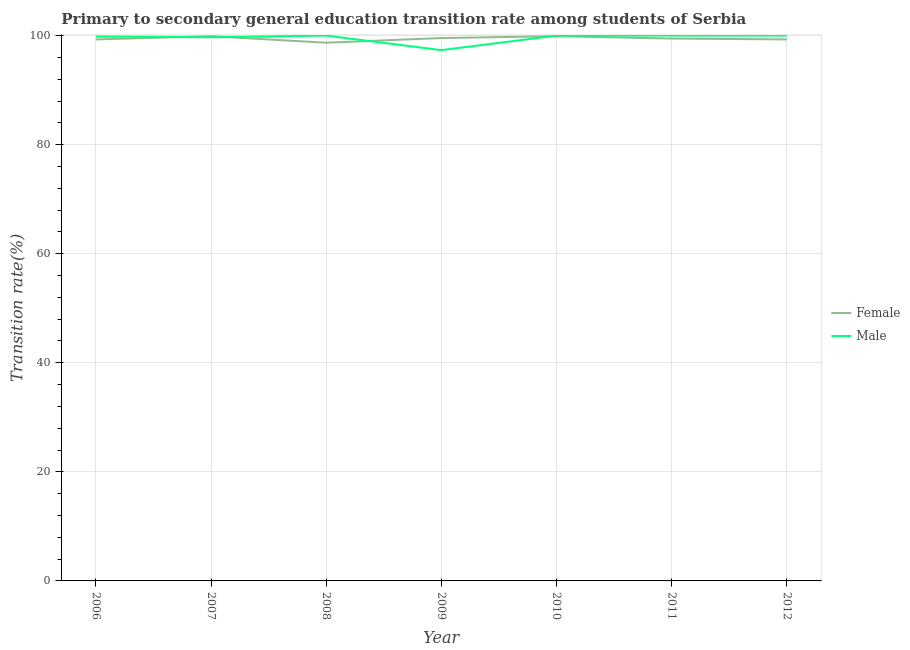How many different coloured lines are there?
Provide a short and direct response. 2. Is the number of lines equal to the number of legend labels?
Your answer should be very brief. Yes. What is the transition rate among female students in 2009?
Make the answer very short. 99.55. Across all years, what is the maximum transition rate among male students?
Offer a terse response. 100. Across all years, what is the minimum transition rate among female students?
Ensure brevity in your answer.  98.7. In which year was the transition rate among male students maximum?
Your answer should be compact. 2008. In which year was the transition rate among female students minimum?
Make the answer very short. 2008. What is the total transition rate among male students in the graph?
Make the answer very short. 696.86. What is the difference between the transition rate among female students in 2007 and that in 2008?
Offer a very short reply. 1.19. What is the difference between the transition rate among male students in 2011 and the transition rate among female students in 2010?
Your answer should be very brief. 0.11. What is the average transition rate among female students per year?
Your answer should be compact. 99.44. In the year 2011, what is the difference between the transition rate among male students and transition rate among female students?
Offer a very short reply. 0.54. In how many years, is the transition rate among male students greater than 52 %?
Offer a terse response. 7. Is the transition rate among male students in 2009 less than that in 2012?
Offer a very short reply. Yes. What is the difference between the highest and the second highest transition rate among female students?
Your response must be concise. 0.01. What is the difference between the highest and the lowest transition rate among female students?
Offer a very short reply. 1.2. In how many years, is the transition rate among female students greater than the average transition rate among female students taken over all years?
Offer a terse response. 4. Is the sum of the transition rate among male students in 2007 and 2010 greater than the maximum transition rate among female students across all years?
Provide a succinct answer. Yes. Does the transition rate among male students monotonically increase over the years?
Your answer should be compact. No. How many years are there in the graph?
Make the answer very short. 7. What is the difference between two consecutive major ticks on the Y-axis?
Your answer should be very brief. 20. Does the graph contain any zero values?
Your response must be concise. No. Does the graph contain grids?
Your answer should be very brief. Yes. Where does the legend appear in the graph?
Offer a terse response. Center right. How many legend labels are there?
Provide a short and direct response. 2. How are the legend labels stacked?
Offer a terse response. Vertical. What is the title of the graph?
Offer a terse response. Primary to secondary general education transition rate among students of Serbia. What is the label or title of the X-axis?
Keep it short and to the point. Year. What is the label or title of the Y-axis?
Give a very brief answer. Transition rate(%). What is the Transition rate(%) in Female in 2006?
Provide a succinct answer. 99.3. What is the Transition rate(%) of Male in 2006?
Your answer should be very brief. 99.83. What is the Transition rate(%) of Female in 2007?
Keep it short and to the point. 99.88. What is the Transition rate(%) in Male in 2007?
Keep it short and to the point. 99.69. What is the Transition rate(%) in Female in 2008?
Give a very brief answer. 98.7. What is the Transition rate(%) in Female in 2009?
Provide a succinct answer. 99.55. What is the Transition rate(%) of Male in 2009?
Ensure brevity in your answer.  97.33. What is the Transition rate(%) in Female in 2010?
Provide a succinct answer. 99.89. What is the Transition rate(%) in Female in 2011?
Offer a terse response. 99.46. What is the Transition rate(%) of Male in 2011?
Give a very brief answer. 100. What is the Transition rate(%) of Female in 2012?
Provide a succinct answer. 99.3. Across all years, what is the maximum Transition rate(%) of Female?
Ensure brevity in your answer.  99.89. Across all years, what is the maximum Transition rate(%) in Male?
Make the answer very short. 100. Across all years, what is the minimum Transition rate(%) in Female?
Offer a very short reply. 98.7. Across all years, what is the minimum Transition rate(%) in Male?
Your response must be concise. 97.33. What is the total Transition rate(%) in Female in the graph?
Provide a succinct answer. 696.08. What is the total Transition rate(%) of Male in the graph?
Make the answer very short. 696.86. What is the difference between the Transition rate(%) of Female in 2006 and that in 2007?
Give a very brief answer. -0.59. What is the difference between the Transition rate(%) of Male in 2006 and that in 2007?
Offer a very short reply. 0.14. What is the difference between the Transition rate(%) of Female in 2006 and that in 2008?
Provide a short and direct response. 0.6. What is the difference between the Transition rate(%) in Male in 2006 and that in 2008?
Your answer should be compact. -0.17. What is the difference between the Transition rate(%) of Female in 2006 and that in 2009?
Offer a very short reply. -0.25. What is the difference between the Transition rate(%) in Male in 2006 and that in 2009?
Keep it short and to the point. 2.5. What is the difference between the Transition rate(%) of Female in 2006 and that in 2010?
Your answer should be compact. -0.59. What is the difference between the Transition rate(%) of Male in 2006 and that in 2010?
Your answer should be very brief. -0.17. What is the difference between the Transition rate(%) of Female in 2006 and that in 2011?
Give a very brief answer. -0.16. What is the difference between the Transition rate(%) of Male in 2006 and that in 2011?
Offer a terse response. -0.17. What is the difference between the Transition rate(%) in Female in 2006 and that in 2012?
Make the answer very short. 0. What is the difference between the Transition rate(%) in Male in 2006 and that in 2012?
Keep it short and to the point. -0.17. What is the difference between the Transition rate(%) in Female in 2007 and that in 2008?
Your answer should be very brief. 1.19. What is the difference between the Transition rate(%) of Male in 2007 and that in 2008?
Ensure brevity in your answer.  -0.31. What is the difference between the Transition rate(%) of Female in 2007 and that in 2009?
Offer a terse response. 0.33. What is the difference between the Transition rate(%) in Male in 2007 and that in 2009?
Offer a very short reply. 2.36. What is the difference between the Transition rate(%) in Female in 2007 and that in 2010?
Ensure brevity in your answer.  -0.01. What is the difference between the Transition rate(%) in Male in 2007 and that in 2010?
Ensure brevity in your answer.  -0.31. What is the difference between the Transition rate(%) in Female in 2007 and that in 2011?
Provide a succinct answer. 0.43. What is the difference between the Transition rate(%) of Male in 2007 and that in 2011?
Give a very brief answer. -0.31. What is the difference between the Transition rate(%) in Female in 2007 and that in 2012?
Offer a very short reply. 0.59. What is the difference between the Transition rate(%) in Male in 2007 and that in 2012?
Your answer should be very brief. -0.31. What is the difference between the Transition rate(%) in Female in 2008 and that in 2009?
Your response must be concise. -0.86. What is the difference between the Transition rate(%) in Male in 2008 and that in 2009?
Give a very brief answer. 2.67. What is the difference between the Transition rate(%) in Female in 2008 and that in 2010?
Your answer should be very brief. -1.2. What is the difference between the Transition rate(%) in Female in 2008 and that in 2011?
Offer a very short reply. -0.76. What is the difference between the Transition rate(%) in Female in 2008 and that in 2012?
Offer a very short reply. -0.6. What is the difference between the Transition rate(%) of Male in 2008 and that in 2012?
Keep it short and to the point. 0. What is the difference between the Transition rate(%) of Female in 2009 and that in 2010?
Keep it short and to the point. -0.34. What is the difference between the Transition rate(%) in Male in 2009 and that in 2010?
Your response must be concise. -2.67. What is the difference between the Transition rate(%) in Female in 2009 and that in 2011?
Give a very brief answer. 0.09. What is the difference between the Transition rate(%) of Male in 2009 and that in 2011?
Make the answer very short. -2.67. What is the difference between the Transition rate(%) of Female in 2009 and that in 2012?
Your answer should be very brief. 0.25. What is the difference between the Transition rate(%) in Male in 2009 and that in 2012?
Make the answer very short. -2.67. What is the difference between the Transition rate(%) in Female in 2010 and that in 2011?
Keep it short and to the point. 0.43. What is the difference between the Transition rate(%) in Female in 2010 and that in 2012?
Your answer should be very brief. 0.59. What is the difference between the Transition rate(%) of Female in 2011 and that in 2012?
Your answer should be compact. 0.16. What is the difference between the Transition rate(%) in Female in 2006 and the Transition rate(%) in Male in 2007?
Ensure brevity in your answer.  -0.39. What is the difference between the Transition rate(%) of Female in 2006 and the Transition rate(%) of Male in 2008?
Keep it short and to the point. -0.7. What is the difference between the Transition rate(%) of Female in 2006 and the Transition rate(%) of Male in 2009?
Your answer should be compact. 1.96. What is the difference between the Transition rate(%) in Female in 2006 and the Transition rate(%) in Male in 2010?
Provide a succinct answer. -0.7. What is the difference between the Transition rate(%) of Female in 2006 and the Transition rate(%) of Male in 2011?
Your response must be concise. -0.7. What is the difference between the Transition rate(%) of Female in 2006 and the Transition rate(%) of Male in 2012?
Provide a short and direct response. -0.7. What is the difference between the Transition rate(%) of Female in 2007 and the Transition rate(%) of Male in 2008?
Give a very brief answer. -0.12. What is the difference between the Transition rate(%) of Female in 2007 and the Transition rate(%) of Male in 2009?
Provide a succinct answer. 2.55. What is the difference between the Transition rate(%) in Female in 2007 and the Transition rate(%) in Male in 2010?
Your answer should be very brief. -0.12. What is the difference between the Transition rate(%) of Female in 2007 and the Transition rate(%) of Male in 2011?
Make the answer very short. -0.12. What is the difference between the Transition rate(%) of Female in 2007 and the Transition rate(%) of Male in 2012?
Ensure brevity in your answer.  -0.12. What is the difference between the Transition rate(%) of Female in 2008 and the Transition rate(%) of Male in 2009?
Keep it short and to the point. 1.36. What is the difference between the Transition rate(%) of Female in 2008 and the Transition rate(%) of Male in 2010?
Keep it short and to the point. -1.3. What is the difference between the Transition rate(%) of Female in 2008 and the Transition rate(%) of Male in 2011?
Offer a very short reply. -1.3. What is the difference between the Transition rate(%) in Female in 2008 and the Transition rate(%) in Male in 2012?
Provide a short and direct response. -1.3. What is the difference between the Transition rate(%) of Female in 2009 and the Transition rate(%) of Male in 2010?
Ensure brevity in your answer.  -0.45. What is the difference between the Transition rate(%) in Female in 2009 and the Transition rate(%) in Male in 2011?
Your response must be concise. -0.45. What is the difference between the Transition rate(%) of Female in 2009 and the Transition rate(%) of Male in 2012?
Provide a short and direct response. -0.45. What is the difference between the Transition rate(%) of Female in 2010 and the Transition rate(%) of Male in 2011?
Your response must be concise. -0.11. What is the difference between the Transition rate(%) of Female in 2010 and the Transition rate(%) of Male in 2012?
Provide a short and direct response. -0.11. What is the difference between the Transition rate(%) in Female in 2011 and the Transition rate(%) in Male in 2012?
Your answer should be very brief. -0.54. What is the average Transition rate(%) of Female per year?
Provide a short and direct response. 99.44. What is the average Transition rate(%) of Male per year?
Ensure brevity in your answer.  99.55. In the year 2006, what is the difference between the Transition rate(%) in Female and Transition rate(%) in Male?
Your answer should be very brief. -0.53. In the year 2007, what is the difference between the Transition rate(%) of Female and Transition rate(%) of Male?
Ensure brevity in your answer.  0.19. In the year 2008, what is the difference between the Transition rate(%) of Female and Transition rate(%) of Male?
Ensure brevity in your answer.  -1.3. In the year 2009, what is the difference between the Transition rate(%) in Female and Transition rate(%) in Male?
Ensure brevity in your answer.  2.22. In the year 2010, what is the difference between the Transition rate(%) of Female and Transition rate(%) of Male?
Your answer should be very brief. -0.11. In the year 2011, what is the difference between the Transition rate(%) of Female and Transition rate(%) of Male?
Ensure brevity in your answer.  -0.54. In the year 2012, what is the difference between the Transition rate(%) in Female and Transition rate(%) in Male?
Make the answer very short. -0.7. What is the ratio of the Transition rate(%) of Female in 2006 to that in 2007?
Your answer should be very brief. 0.99. What is the ratio of the Transition rate(%) in Male in 2006 to that in 2007?
Your answer should be compact. 1. What is the ratio of the Transition rate(%) of Female in 2006 to that in 2008?
Provide a short and direct response. 1.01. What is the ratio of the Transition rate(%) in Male in 2006 to that in 2009?
Make the answer very short. 1.03. What is the ratio of the Transition rate(%) in Male in 2006 to that in 2011?
Make the answer very short. 1. What is the ratio of the Transition rate(%) of Female in 2006 to that in 2012?
Your answer should be compact. 1. What is the ratio of the Transition rate(%) in Male in 2006 to that in 2012?
Offer a very short reply. 1. What is the ratio of the Transition rate(%) in Female in 2007 to that in 2008?
Give a very brief answer. 1.01. What is the ratio of the Transition rate(%) of Male in 2007 to that in 2008?
Your response must be concise. 1. What is the ratio of the Transition rate(%) in Female in 2007 to that in 2009?
Provide a short and direct response. 1. What is the ratio of the Transition rate(%) in Male in 2007 to that in 2009?
Make the answer very short. 1.02. What is the ratio of the Transition rate(%) of Female in 2007 to that in 2011?
Provide a succinct answer. 1. What is the ratio of the Transition rate(%) of Male in 2007 to that in 2011?
Your response must be concise. 1. What is the ratio of the Transition rate(%) of Female in 2007 to that in 2012?
Give a very brief answer. 1.01. What is the ratio of the Transition rate(%) in Male in 2007 to that in 2012?
Your answer should be compact. 1. What is the ratio of the Transition rate(%) in Female in 2008 to that in 2009?
Offer a terse response. 0.99. What is the ratio of the Transition rate(%) in Male in 2008 to that in 2009?
Provide a succinct answer. 1.03. What is the ratio of the Transition rate(%) in Female in 2008 to that in 2010?
Keep it short and to the point. 0.99. What is the ratio of the Transition rate(%) in Male in 2008 to that in 2011?
Provide a short and direct response. 1. What is the ratio of the Transition rate(%) in Female in 2008 to that in 2012?
Provide a succinct answer. 0.99. What is the ratio of the Transition rate(%) of Male in 2008 to that in 2012?
Your response must be concise. 1. What is the ratio of the Transition rate(%) of Female in 2009 to that in 2010?
Offer a terse response. 1. What is the ratio of the Transition rate(%) of Male in 2009 to that in 2010?
Offer a terse response. 0.97. What is the ratio of the Transition rate(%) in Female in 2009 to that in 2011?
Offer a terse response. 1. What is the ratio of the Transition rate(%) of Male in 2009 to that in 2011?
Your answer should be very brief. 0.97. What is the ratio of the Transition rate(%) in Male in 2009 to that in 2012?
Your answer should be compact. 0.97. What is the ratio of the Transition rate(%) in Female in 2010 to that in 2011?
Ensure brevity in your answer.  1. What is the ratio of the Transition rate(%) of Male in 2010 to that in 2011?
Offer a very short reply. 1. What is the ratio of the Transition rate(%) of Female in 2010 to that in 2012?
Ensure brevity in your answer.  1.01. What is the difference between the highest and the second highest Transition rate(%) in Female?
Offer a terse response. 0.01. What is the difference between the highest and the lowest Transition rate(%) of Female?
Make the answer very short. 1.2. What is the difference between the highest and the lowest Transition rate(%) in Male?
Ensure brevity in your answer.  2.67. 